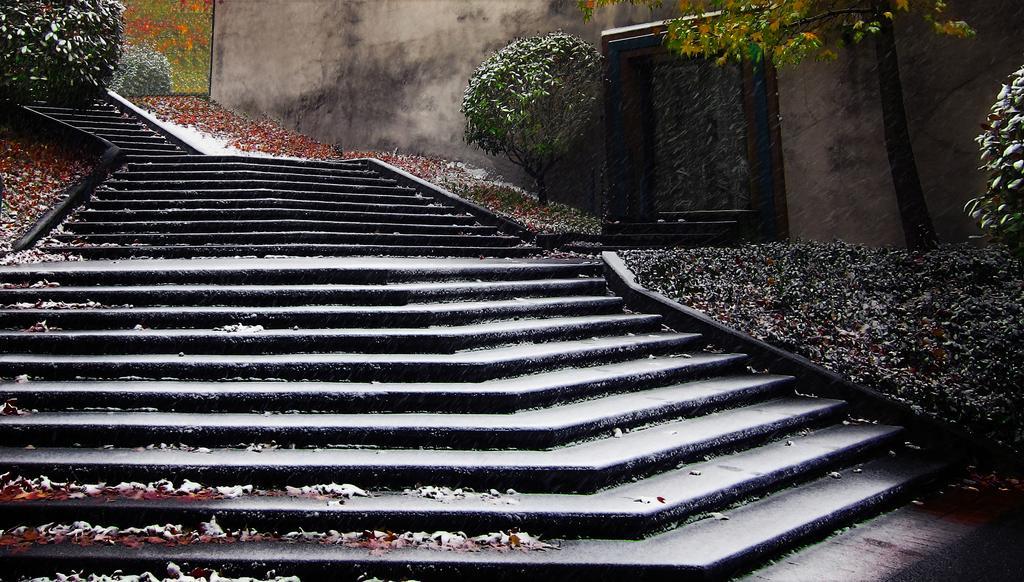How would you summarize this image in a sentence or two? In the image there are stairs and around the stairs there are plants and on the right side there is a wall. 